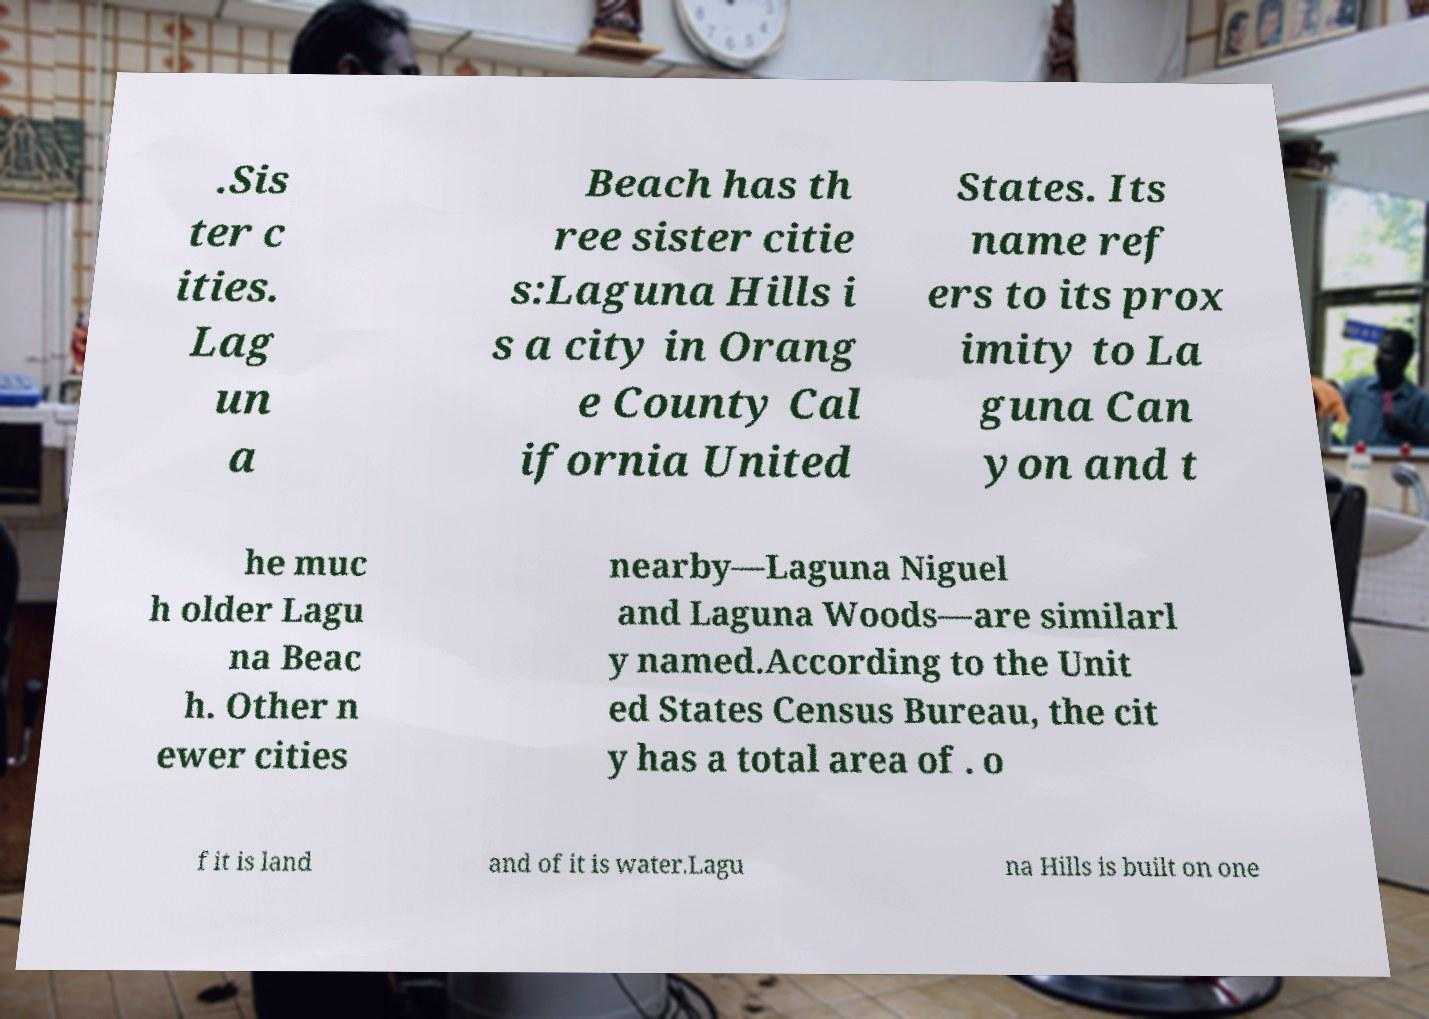What messages or text are displayed in this image? I need them in a readable, typed format. .Sis ter c ities. Lag un a Beach has th ree sister citie s:Laguna Hills i s a city in Orang e County Cal ifornia United States. Its name ref ers to its prox imity to La guna Can yon and t he muc h older Lagu na Beac h. Other n ewer cities nearby—Laguna Niguel and Laguna Woods—are similarl y named.According to the Unit ed States Census Bureau, the cit y has a total area of . o f it is land and of it is water.Lagu na Hills is built on one 